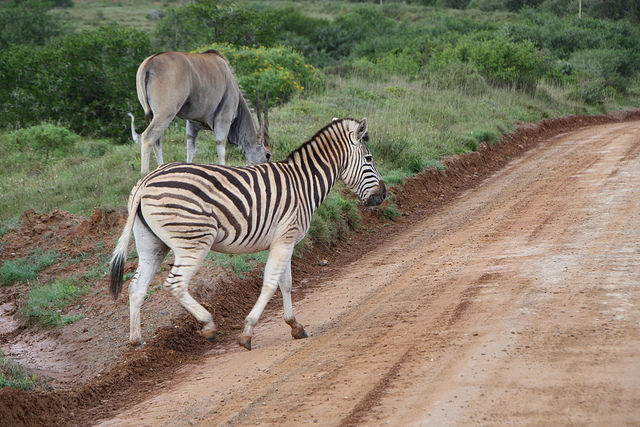What are the two animals in the image, and how can you distinguish between them? The image shows a zebra in the foreground and what appears to be an antelope or a similar ungulate in the background. You can distinguish between them by their distinct coat patterns and colors. The zebra has black and white stripes, unique to its species, while the other animal has a solid coloring with a lighter tone and doesn't have any stripes. Additionally, their body shapes differ; zebras have a more robust, horse-like build, while this antelope has a leaner frame and longer legs in proportion to its body. 